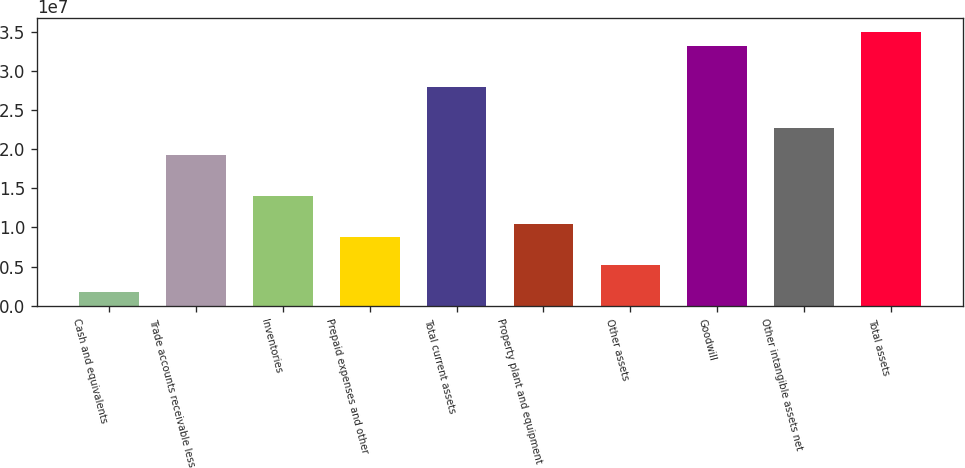Convert chart. <chart><loc_0><loc_0><loc_500><loc_500><bar_chart><fcel>Cash and equivalents<fcel>Trade accounts receivable less<fcel>Inventories<fcel>Prepaid expenses and other<fcel>Total current assets<fcel>Property plant and equipment<fcel>Other assets<fcel>Goodwill<fcel>Other intangible assets net<fcel>Total assets<nl><fcel>1.75037e+06<fcel>1.92188e+07<fcel>1.39783e+07<fcel>8.73773e+06<fcel>2.7953e+07<fcel>1.04846e+07<fcel>5.24405e+06<fcel>3.31935e+07<fcel>2.27125e+07<fcel>3.49403e+07<nl></chart> 